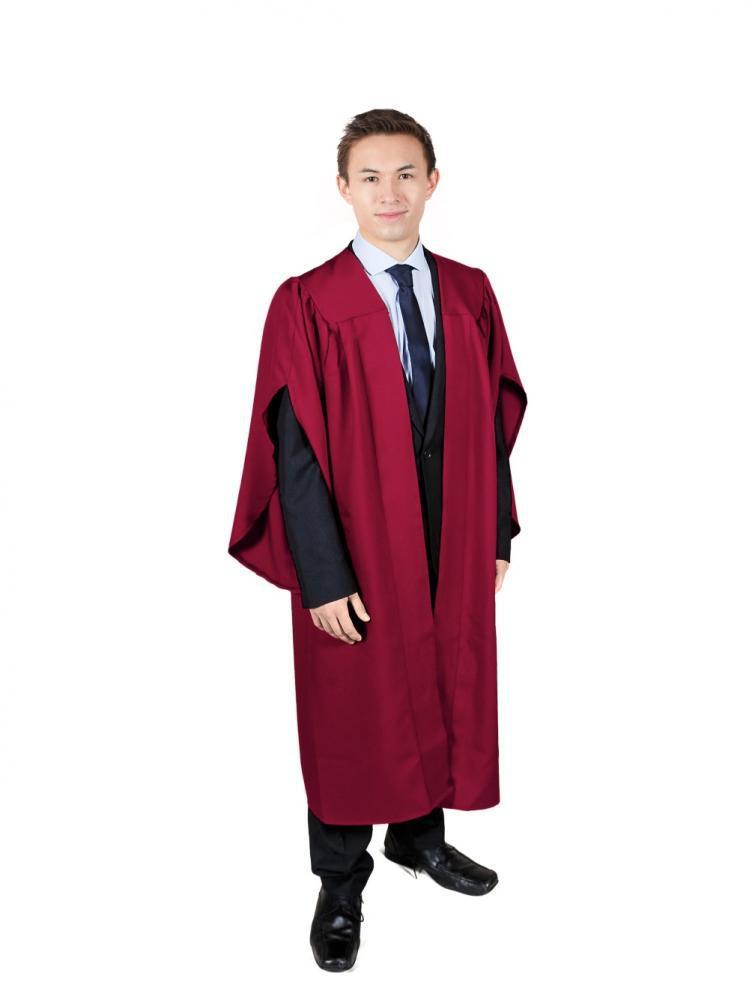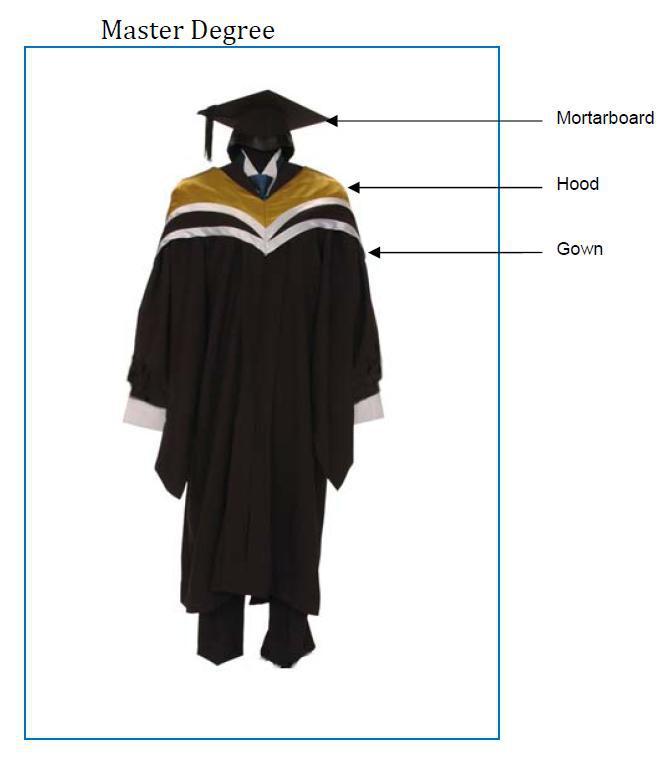The first image is the image on the left, the second image is the image on the right. Considering the images on both sides, is "Only two different people wearing gowns are visible." valid? Answer yes or no. No. 